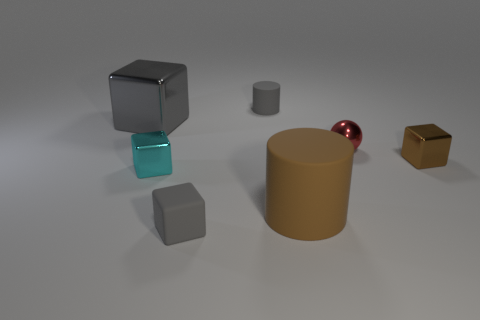Subtract all green cubes. Subtract all gray cylinders. How many cubes are left? 4 Add 1 cyan metallic objects. How many objects exist? 8 Subtract all blocks. How many objects are left? 3 Add 3 gray metal cubes. How many gray metal cubes are left? 4 Add 2 big purple cubes. How many big purple cubes exist? 2 Subtract 1 cyan blocks. How many objects are left? 6 Subtract all large yellow matte cubes. Subtract all small cyan blocks. How many objects are left? 6 